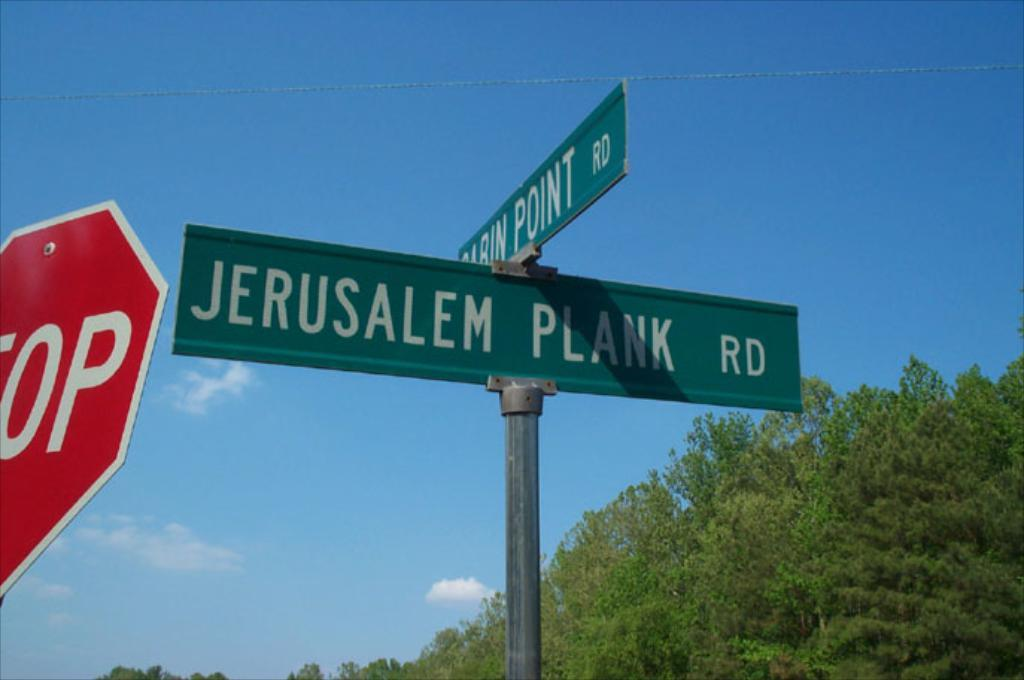<image>
Render a clear and concise summary of the photo. A red stop sign is next to Jerusalem Plank Rd street sign. 